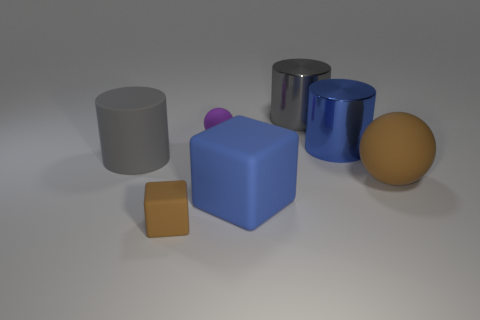Add 3 brown objects. How many objects exist? 10 Subtract all cubes. How many objects are left? 5 Add 4 tiny red matte objects. How many tiny red matte objects exist? 4 Subtract 0 red spheres. How many objects are left? 7 Subtract all small rubber things. Subtract all green metal cylinders. How many objects are left? 5 Add 2 cylinders. How many cylinders are left? 5 